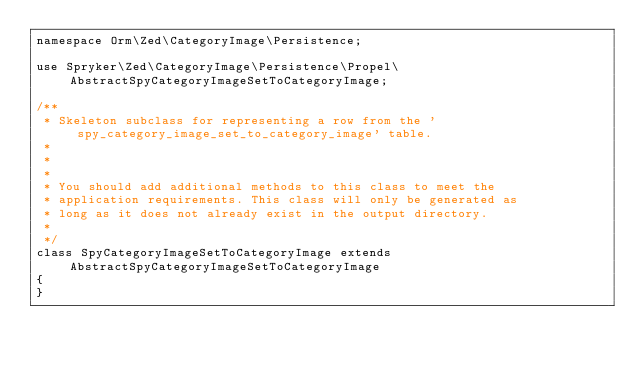<code> <loc_0><loc_0><loc_500><loc_500><_PHP_>namespace Orm\Zed\CategoryImage\Persistence;

use Spryker\Zed\CategoryImage\Persistence\Propel\AbstractSpyCategoryImageSetToCategoryImage;

/**
 * Skeleton subclass for representing a row from the 'spy_category_image_set_to_category_image' table.
 *
 *
 *
 * You should add additional methods to this class to meet the
 * application requirements. This class will only be generated as
 * long as it does not already exist in the output directory.
 *
 */
class SpyCategoryImageSetToCategoryImage extends AbstractSpyCategoryImageSetToCategoryImage
{
}
</code> 